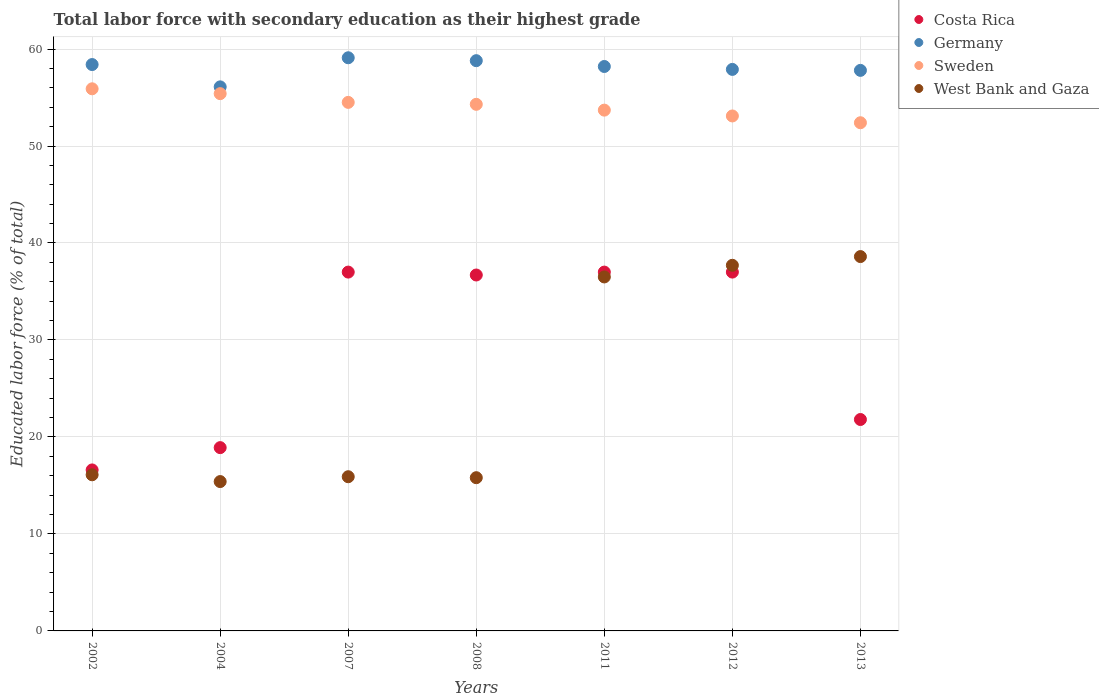How many different coloured dotlines are there?
Your answer should be compact. 4. Is the number of dotlines equal to the number of legend labels?
Keep it short and to the point. Yes. What is the percentage of total labor force with primary education in West Bank and Gaza in 2002?
Make the answer very short. 16.1. Across all years, what is the maximum percentage of total labor force with primary education in Costa Rica?
Give a very brief answer. 37. Across all years, what is the minimum percentage of total labor force with primary education in Sweden?
Give a very brief answer. 52.4. What is the total percentage of total labor force with primary education in Sweden in the graph?
Offer a terse response. 379.3. What is the difference between the percentage of total labor force with primary education in Costa Rica in 2004 and that in 2011?
Provide a succinct answer. -18.1. What is the difference between the percentage of total labor force with primary education in Sweden in 2002 and the percentage of total labor force with primary education in West Bank and Gaza in 2013?
Offer a very short reply. 17.3. What is the average percentage of total labor force with primary education in Costa Rica per year?
Your answer should be compact. 29.29. In the year 2007, what is the difference between the percentage of total labor force with primary education in Germany and percentage of total labor force with primary education in West Bank and Gaza?
Your response must be concise. 43.2. What is the ratio of the percentage of total labor force with primary education in Costa Rica in 2012 to that in 2013?
Provide a succinct answer. 1.7. Is the percentage of total labor force with primary education in Sweden in 2007 less than that in 2008?
Your answer should be very brief. No. What is the difference between the highest and the second highest percentage of total labor force with primary education in Sweden?
Offer a terse response. 0.5. Is the sum of the percentage of total labor force with primary education in Costa Rica in 2011 and 2012 greater than the maximum percentage of total labor force with primary education in West Bank and Gaza across all years?
Ensure brevity in your answer.  Yes. Is it the case that in every year, the sum of the percentage of total labor force with primary education in Germany and percentage of total labor force with primary education in West Bank and Gaza  is greater than the sum of percentage of total labor force with primary education in Sweden and percentage of total labor force with primary education in Costa Rica?
Keep it short and to the point. Yes. Does the percentage of total labor force with primary education in Germany monotonically increase over the years?
Offer a very short reply. No. Is the percentage of total labor force with primary education in West Bank and Gaza strictly greater than the percentage of total labor force with primary education in Sweden over the years?
Give a very brief answer. No. Is the percentage of total labor force with primary education in Costa Rica strictly less than the percentage of total labor force with primary education in West Bank and Gaza over the years?
Your response must be concise. No. How many dotlines are there?
Keep it short and to the point. 4. Are the values on the major ticks of Y-axis written in scientific E-notation?
Make the answer very short. No. Does the graph contain any zero values?
Your answer should be compact. No. Does the graph contain grids?
Provide a short and direct response. Yes. How are the legend labels stacked?
Offer a terse response. Vertical. What is the title of the graph?
Offer a terse response. Total labor force with secondary education as their highest grade. Does "Libya" appear as one of the legend labels in the graph?
Your answer should be compact. No. What is the label or title of the X-axis?
Provide a succinct answer. Years. What is the label or title of the Y-axis?
Your answer should be compact. Educated labor force (% of total). What is the Educated labor force (% of total) in Costa Rica in 2002?
Provide a short and direct response. 16.6. What is the Educated labor force (% of total) in Germany in 2002?
Give a very brief answer. 58.4. What is the Educated labor force (% of total) of Sweden in 2002?
Ensure brevity in your answer.  55.9. What is the Educated labor force (% of total) of West Bank and Gaza in 2002?
Provide a succinct answer. 16.1. What is the Educated labor force (% of total) in Costa Rica in 2004?
Ensure brevity in your answer.  18.9. What is the Educated labor force (% of total) of Germany in 2004?
Your answer should be very brief. 56.1. What is the Educated labor force (% of total) of Sweden in 2004?
Offer a terse response. 55.4. What is the Educated labor force (% of total) of West Bank and Gaza in 2004?
Offer a terse response. 15.4. What is the Educated labor force (% of total) in Costa Rica in 2007?
Your response must be concise. 37. What is the Educated labor force (% of total) in Germany in 2007?
Your answer should be very brief. 59.1. What is the Educated labor force (% of total) of Sweden in 2007?
Offer a very short reply. 54.5. What is the Educated labor force (% of total) in West Bank and Gaza in 2007?
Your response must be concise. 15.9. What is the Educated labor force (% of total) of Costa Rica in 2008?
Offer a very short reply. 36.7. What is the Educated labor force (% of total) in Germany in 2008?
Your answer should be very brief. 58.8. What is the Educated labor force (% of total) in Sweden in 2008?
Keep it short and to the point. 54.3. What is the Educated labor force (% of total) of West Bank and Gaza in 2008?
Ensure brevity in your answer.  15.8. What is the Educated labor force (% of total) of Germany in 2011?
Your response must be concise. 58.2. What is the Educated labor force (% of total) in Sweden in 2011?
Provide a succinct answer. 53.7. What is the Educated labor force (% of total) of West Bank and Gaza in 2011?
Provide a short and direct response. 36.5. What is the Educated labor force (% of total) of Costa Rica in 2012?
Provide a short and direct response. 37. What is the Educated labor force (% of total) of Germany in 2012?
Provide a succinct answer. 57.9. What is the Educated labor force (% of total) of Sweden in 2012?
Keep it short and to the point. 53.1. What is the Educated labor force (% of total) in West Bank and Gaza in 2012?
Offer a very short reply. 37.7. What is the Educated labor force (% of total) in Costa Rica in 2013?
Make the answer very short. 21.8. What is the Educated labor force (% of total) in Germany in 2013?
Keep it short and to the point. 57.8. What is the Educated labor force (% of total) in Sweden in 2013?
Provide a short and direct response. 52.4. What is the Educated labor force (% of total) in West Bank and Gaza in 2013?
Provide a succinct answer. 38.6. Across all years, what is the maximum Educated labor force (% of total) of Costa Rica?
Your response must be concise. 37. Across all years, what is the maximum Educated labor force (% of total) in Germany?
Make the answer very short. 59.1. Across all years, what is the maximum Educated labor force (% of total) in Sweden?
Your response must be concise. 55.9. Across all years, what is the maximum Educated labor force (% of total) in West Bank and Gaza?
Ensure brevity in your answer.  38.6. Across all years, what is the minimum Educated labor force (% of total) of Costa Rica?
Your response must be concise. 16.6. Across all years, what is the minimum Educated labor force (% of total) in Germany?
Your answer should be compact. 56.1. Across all years, what is the minimum Educated labor force (% of total) in Sweden?
Your response must be concise. 52.4. Across all years, what is the minimum Educated labor force (% of total) of West Bank and Gaza?
Your answer should be very brief. 15.4. What is the total Educated labor force (% of total) in Costa Rica in the graph?
Keep it short and to the point. 205. What is the total Educated labor force (% of total) in Germany in the graph?
Provide a succinct answer. 406.3. What is the total Educated labor force (% of total) of Sweden in the graph?
Your response must be concise. 379.3. What is the total Educated labor force (% of total) in West Bank and Gaza in the graph?
Make the answer very short. 176. What is the difference between the Educated labor force (% of total) in Costa Rica in 2002 and that in 2004?
Provide a succinct answer. -2.3. What is the difference between the Educated labor force (% of total) of West Bank and Gaza in 2002 and that in 2004?
Your answer should be very brief. 0.7. What is the difference between the Educated labor force (% of total) of Costa Rica in 2002 and that in 2007?
Offer a terse response. -20.4. What is the difference between the Educated labor force (% of total) of Germany in 2002 and that in 2007?
Offer a very short reply. -0.7. What is the difference between the Educated labor force (% of total) of Costa Rica in 2002 and that in 2008?
Ensure brevity in your answer.  -20.1. What is the difference between the Educated labor force (% of total) in West Bank and Gaza in 2002 and that in 2008?
Ensure brevity in your answer.  0.3. What is the difference between the Educated labor force (% of total) in Costa Rica in 2002 and that in 2011?
Ensure brevity in your answer.  -20.4. What is the difference between the Educated labor force (% of total) of West Bank and Gaza in 2002 and that in 2011?
Keep it short and to the point. -20.4. What is the difference between the Educated labor force (% of total) of Costa Rica in 2002 and that in 2012?
Your answer should be compact. -20.4. What is the difference between the Educated labor force (% of total) of Germany in 2002 and that in 2012?
Offer a terse response. 0.5. What is the difference between the Educated labor force (% of total) in West Bank and Gaza in 2002 and that in 2012?
Your answer should be very brief. -21.6. What is the difference between the Educated labor force (% of total) of Germany in 2002 and that in 2013?
Provide a succinct answer. 0.6. What is the difference between the Educated labor force (% of total) in West Bank and Gaza in 2002 and that in 2013?
Your answer should be very brief. -22.5. What is the difference between the Educated labor force (% of total) of Costa Rica in 2004 and that in 2007?
Your response must be concise. -18.1. What is the difference between the Educated labor force (% of total) of Costa Rica in 2004 and that in 2008?
Make the answer very short. -17.8. What is the difference between the Educated labor force (% of total) in Germany in 2004 and that in 2008?
Your response must be concise. -2.7. What is the difference between the Educated labor force (% of total) of Sweden in 2004 and that in 2008?
Provide a succinct answer. 1.1. What is the difference between the Educated labor force (% of total) of Costa Rica in 2004 and that in 2011?
Your response must be concise. -18.1. What is the difference between the Educated labor force (% of total) of West Bank and Gaza in 2004 and that in 2011?
Provide a succinct answer. -21.1. What is the difference between the Educated labor force (% of total) of Costa Rica in 2004 and that in 2012?
Provide a succinct answer. -18.1. What is the difference between the Educated labor force (% of total) of West Bank and Gaza in 2004 and that in 2012?
Offer a terse response. -22.3. What is the difference between the Educated labor force (% of total) in Germany in 2004 and that in 2013?
Ensure brevity in your answer.  -1.7. What is the difference between the Educated labor force (% of total) of Sweden in 2004 and that in 2013?
Your answer should be very brief. 3. What is the difference between the Educated labor force (% of total) of West Bank and Gaza in 2004 and that in 2013?
Give a very brief answer. -23.2. What is the difference between the Educated labor force (% of total) of Costa Rica in 2007 and that in 2008?
Ensure brevity in your answer.  0.3. What is the difference between the Educated labor force (% of total) of Germany in 2007 and that in 2008?
Offer a very short reply. 0.3. What is the difference between the Educated labor force (% of total) of Sweden in 2007 and that in 2008?
Offer a terse response. 0.2. What is the difference between the Educated labor force (% of total) of Germany in 2007 and that in 2011?
Provide a short and direct response. 0.9. What is the difference between the Educated labor force (% of total) of West Bank and Gaza in 2007 and that in 2011?
Ensure brevity in your answer.  -20.6. What is the difference between the Educated labor force (% of total) in Costa Rica in 2007 and that in 2012?
Your answer should be very brief. 0. What is the difference between the Educated labor force (% of total) in Germany in 2007 and that in 2012?
Ensure brevity in your answer.  1.2. What is the difference between the Educated labor force (% of total) of Sweden in 2007 and that in 2012?
Provide a short and direct response. 1.4. What is the difference between the Educated labor force (% of total) in West Bank and Gaza in 2007 and that in 2012?
Your answer should be compact. -21.8. What is the difference between the Educated labor force (% of total) of Costa Rica in 2007 and that in 2013?
Provide a short and direct response. 15.2. What is the difference between the Educated labor force (% of total) of Sweden in 2007 and that in 2013?
Keep it short and to the point. 2.1. What is the difference between the Educated labor force (% of total) in West Bank and Gaza in 2007 and that in 2013?
Your answer should be very brief. -22.7. What is the difference between the Educated labor force (% of total) of Costa Rica in 2008 and that in 2011?
Provide a short and direct response. -0.3. What is the difference between the Educated labor force (% of total) in Sweden in 2008 and that in 2011?
Make the answer very short. 0.6. What is the difference between the Educated labor force (% of total) in West Bank and Gaza in 2008 and that in 2011?
Offer a very short reply. -20.7. What is the difference between the Educated labor force (% of total) of Germany in 2008 and that in 2012?
Offer a terse response. 0.9. What is the difference between the Educated labor force (% of total) in Sweden in 2008 and that in 2012?
Offer a very short reply. 1.2. What is the difference between the Educated labor force (% of total) in West Bank and Gaza in 2008 and that in 2012?
Offer a terse response. -21.9. What is the difference between the Educated labor force (% of total) of Germany in 2008 and that in 2013?
Your response must be concise. 1. What is the difference between the Educated labor force (% of total) in West Bank and Gaza in 2008 and that in 2013?
Make the answer very short. -22.8. What is the difference between the Educated labor force (% of total) of Costa Rica in 2011 and that in 2012?
Your response must be concise. 0. What is the difference between the Educated labor force (% of total) of Germany in 2011 and that in 2012?
Provide a short and direct response. 0.3. What is the difference between the Educated labor force (% of total) in Sweden in 2011 and that in 2013?
Your answer should be compact. 1.3. What is the difference between the Educated labor force (% of total) in Germany in 2012 and that in 2013?
Provide a succinct answer. 0.1. What is the difference between the Educated labor force (% of total) in West Bank and Gaza in 2012 and that in 2013?
Your answer should be compact. -0.9. What is the difference between the Educated labor force (% of total) of Costa Rica in 2002 and the Educated labor force (% of total) of Germany in 2004?
Your answer should be very brief. -39.5. What is the difference between the Educated labor force (% of total) of Costa Rica in 2002 and the Educated labor force (% of total) of Sweden in 2004?
Provide a succinct answer. -38.8. What is the difference between the Educated labor force (% of total) in Costa Rica in 2002 and the Educated labor force (% of total) in West Bank and Gaza in 2004?
Provide a short and direct response. 1.2. What is the difference between the Educated labor force (% of total) in Germany in 2002 and the Educated labor force (% of total) in West Bank and Gaza in 2004?
Give a very brief answer. 43. What is the difference between the Educated labor force (% of total) in Sweden in 2002 and the Educated labor force (% of total) in West Bank and Gaza in 2004?
Ensure brevity in your answer.  40.5. What is the difference between the Educated labor force (% of total) of Costa Rica in 2002 and the Educated labor force (% of total) of Germany in 2007?
Give a very brief answer. -42.5. What is the difference between the Educated labor force (% of total) in Costa Rica in 2002 and the Educated labor force (% of total) in Sweden in 2007?
Offer a very short reply. -37.9. What is the difference between the Educated labor force (% of total) in Germany in 2002 and the Educated labor force (% of total) in Sweden in 2007?
Your answer should be very brief. 3.9. What is the difference between the Educated labor force (% of total) of Germany in 2002 and the Educated labor force (% of total) of West Bank and Gaza in 2007?
Offer a terse response. 42.5. What is the difference between the Educated labor force (% of total) of Sweden in 2002 and the Educated labor force (% of total) of West Bank and Gaza in 2007?
Make the answer very short. 40. What is the difference between the Educated labor force (% of total) of Costa Rica in 2002 and the Educated labor force (% of total) of Germany in 2008?
Your answer should be very brief. -42.2. What is the difference between the Educated labor force (% of total) in Costa Rica in 2002 and the Educated labor force (% of total) in Sweden in 2008?
Offer a terse response. -37.7. What is the difference between the Educated labor force (% of total) of Germany in 2002 and the Educated labor force (% of total) of Sweden in 2008?
Make the answer very short. 4.1. What is the difference between the Educated labor force (% of total) of Germany in 2002 and the Educated labor force (% of total) of West Bank and Gaza in 2008?
Your answer should be compact. 42.6. What is the difference between the Educated labor force (% of total) in Sweden in 2002 and the Educated labor force (% of total) in West Bank and Gaza in 2008?
Provide a short and direct response. 40.1. What is the difference between the Educated labor force (% of total) of Costa Rica in 2002 and the Educated labor force (% of total) of Germany in 2011?
Provide a short and direct response. -41.6. What is the difference between the Educated labor force (% of total) in Costa Rica in 2002 and the Educated labor force (% of total) in Sweden in 2011?
Ensure brevity in your answer.  -37.1. What is the difference between the Educated labor force (% of total) of Costa Rica in 2002 and the Educated labor force (% of total) of West Bank and Gaza in 2011?
Offer a very short reply. -19.9. What is the difference between the Educated labor force (% of total) of Germany in 2002 and the Educated labor force (% of total) of West Bank and Gaza in 2011?
Ensure brevity in your answer.  21.9. What is the difference between the Educated labor force (% of total) of Costa Rica in 2002 and the Educated labor force (% of total) of Germany in 2012?
Give a very brief answer. -41.3. What is the difference between the Educated labor force (% of total) of Costa Rica in 2002 and the Educated labor force (% of total) of Sweden in 2012?
Offer a very short reply. -36.5. What is the difference between the Educated labor force (% of total) in Costa Rica in 2002 and the Educated labor force (% of total) in West Bank and Gaza in 2012?
Your answer should be compact. -21.1. What is the difference between the Educated labor force (% of total) in Germany in 2002 and the Educated labor force (% of total) in Sweden in 2012?
Your answer should be very brief. 5.3. What is the difference between the Educated labor force (% of total) in Germany in 2002 and the Educated labor force (% of total) in West Bank and Gaza in 2012?
Your answer should be very brief. 20.7. What is the difference between the Educated labor force (% of total) of Sweden in 2002 and the Educated labor force (% of total) of West Bank and Gaza in 2012?
Your response must be concise. 18.2. What is the difference between the Educated labor force (% of total) of Costa Rica in 2002 and the Educated labor force (% of total) of Germany in 2013?
Provide a succinct answer. -41.2. What is the difference between the Educated labor force (% of total) of Costa Rica in 2002 and the Educated labor force (% of total) of Sweden in 2013?
Keep it short and to the point. -35.8. What is the difference between the Educated labor force (% of total) of Germany in 2002 and the Educated labor force (% of total) of Sweden in 2013?
Offer a very short reply. 6. What is the difference between the Educated labor force (% of total) in Germany in 2002 and the Educated labor force (% of total) in West Bank and Gaza in 2013?
Ensure brevity in your answer.  19.8. What is the difference between the Educated labor force (% of total) in Costa Rica in 2004 and the Educated labor force (% of total) in Germany in 2007?
Offer a terse response. -40.2. What is the difference between the Educated labor force (% of total) of Costa Rica in 2004 and the Educated labor force (% of total) of Sweden in 2007?
Make the answer very short. -35.6. What is the difference between the Educated labor force (% of total) in Costa Rica in 2004 and the Educated labor force (% of total) in West Bank and Gaza in 2007?
Offer a very short reply. 3. What is the difference between the Educated labor force (% of total) of Germany in 2004 and the Educated labor force (% of total) of Sweden in 2007?
Your answer should be compact. 1.6. What is the difference between the Educated labor force (% of total) in Germany in 2004 and the Educated labor force (% of total) in West Bank and Gaza in 2007?
Provide a short and direct response. 40.2. What is the difference between the Educated labor force (% of total) of Sweden in 2004 and the Educated labor force (% of total) of West Bank and Gaza in 2007?
Give a very brief answer. 39.5. What is the difference between the Educated labor force (% of total) of Costa Rica in 2004 and the Educated labor force (% of total) of Germany in 2008?
Make the answer very short. -39.9. What is the difference between the Educated labor force (% of total) of Costa Rica in 2004 and the Educated labor force (% of total) of Sweden in 2008?
Your answer should be very brief. -35.4. What is the difference between the Educated labor force (% of total) in Germany in 2004 and the Educated labor force (% of total) in Sweden in 2008?
Provide a succinct answer. 1.8. What is the difference between the Educated labor force (% of total) of Germany in 2004 and the Educated labor force (% of total) of West Bank and Gaza in 2008?
Ensure brevity in your answer.  40.3. What is the difference between the Educated labor force (% of total) of Sweden in 2004 and the Educated labor force (% of total) of West Bank and Gaza in 2008?
Make the answer very short. 39.6. What is the difference between the Educated labor force (% of total) of Costa Rica in 2004 and the Educated labor force (% of total) of Germany in 2011?
Offer a terse response. -39.3. What is the difference between the Educated labor force (% of total) of Costa Rica in 2004 and the Educated labor force (% of total) of Sweden in 2011?
Keep it short and to the point. -34.8. What is the difference between the Educated labor force (% of total) in Costa Rica in 2004 and the Educated labor force (% of total) in West Bank and Gaza in 2011?
Provide a succinct answer. -17.6. What is the difference between the Educated labor force (% of total) in Germany in 2004 and the Educated labor force (% of total) in West Bank and Gaza in 2011?
Give a very brief answer. 19.6. What is the difference between the Educated labor force (% of total) of Sweden in 2004 and the Educated labor force (% of total) of West Bank and Gaza in 2011?
Offer a terse response. 18.9. What is the difference between the Educated labor force (% of total) in Costa Rica in 2004 and the Educated labor force (% of total) in Germany in 2012?
Offer a terse response. -39. What is the difference between the Educated labor force (% of total) in Costa Rica in 2004 and the Educated labor force (% of total) in Sweden in 2012?
Provide a short and direct response. -34.2. What is the difference between the Educated labor force (% of total) in Costa Rica in 2004 and the Educated labor force (% of total) in West Bank and Gaza in 2012?
Your answer should be compact. -18.8. What is the difference between the Educated labor force (% of total) of Germany in 2004 and the Educated labor force (% of total) of West Bank and Gaza in 2012?
Your response must be concise. 18.4. What is the difference between the Educated labor force (% of total) in Costa Rica in 2004 and the Educated labor force (% of total) in Germany in 2013?
Ensure brevity in your answer.  -38.9. What is the difference between the Educated labor force (% of total) of Costa Rica in 2004 and the Educated labor force (% of total) of Sweden in 2013?
Offer a very short reply. -33.5. What is the difference between the Educated labor force (% of total) in Costa Rica in 2004 and the Educated labor force (% of total) in West Bank and Gaza in 2013?
Offer a very short reply. -19.7. What is the difference between the Educated labor force (% of total) in Germany in 2004 and the Educated labor force (% of total) in West Bank and Gaza in 2013?
Offer a very short reply. 17.5. What is the difference between the Educated labor force (% of total) in Costa Rica in 2007 and the Educated labor force (% of total) in Germany in 2008?
Give a very brief answer. -21.8. What is the difference between the Educated labor force (% of total) of Costa Rica in 2007 and the Educated labor force (% of total) of Sweden in 2008?
Your answer should be compact. -17.3. What is the difference between the Educated labor force (% of total) in Costa Rica in 2007 and the Educated labor force (% of total) in West Bank and Gaza in 2008?
Your answer should be compact. 21.2. What is the difference between the Educated labor force (% of total) of Germany in 2007 and the Educated labor force (% of total) of West Bank and Gaza in 2008?
Make the answer very short. 43.3. What is the difference between the Educated labor force (% of total) in Sweden in 2007 and the Educated labor force (% of total) in West Bank and Gaza in 2008?
Ensure brevity in your answer.  38.7. What is the difference between the Educated labor force (% of total) of Costa Rica in 2007 and the Educated labor force (% of total) of Germany in 2011?
Make the answer very short. -21.2. What is the difference between the Educated labor force (% of total) in Costa Rica in 2007 and the Educated labor force (% of total) in Sweden in 2011?
Make the answer very short. -16.7. What is the difference between the Educated labor force (% of total) of Germany in 2007 and the Educated labor force (% of total) of Sweden in 2011?
Keep it short and to the point. 5.4. What is the difference between the Educated labor force (% of total) in Germany in 2007 and the Educated labor force (% of total) in West Bank and Gaza in 2011?
Your response must be concise. 22.6. What is the difference between the Educated labor force (% of total) of Costa Rica in 2007 and the Educated labor force (% of total) of Germany in 2012?
Provide a short and direct response. -20.9. What is the difference between the Educated labor force (% of total) of Costa Rica in 2007 and the Educated labor force (% of total) of Sweden in 2012?
Provide a succinct answer. -16.1. What is the difference between the Educated labor force (% of total) of Costa Rica in 2007 and the Educated labor force (% of total) of West Bank and Gaza in 2012?
Your answer should be compact. -0.7. What is the difference between the Educated labor force (% of total) of Germany in 2007 and the Educated labor force (% of total) of West Bank and Gaza in 2012?
Your response must be concise. 21.4. What is the difference between the Educated labor force (% of total) in Sweden in 2007 and the Educated labor force (% of total) in West Bank and Gaza in 2012?
Make the answer very short. 16.8. What is the difference between the Educated labor force (% of total) of Costa Rica in 2007 and the Educated labor force (% of total) of Germany in 2013?
Offer a very short reply. -20.8. What is the difference between the Educated labor force (% of total) of Costa Rica in 2007 and the Educated labor force (% of total) of Sweden in 2013?
Offer a very short reply. -15.4. What is the difference between the Educated labor force (% of total) in Germany in 2007 and the Educated labor force (% of total) in Sweden in 2013?
Ensure brevity in your answer.  6.7. What is the difference between the Educated labor force (% of total) in Germany in 2007 and the Educated labor force (% of total) in West Bank and Gaza in 2013?
Provide a short and direct response. 20.5. What is the difference between the Educated labor force (% of total) in Costa Rica in 2008 and the Educated labor force (% of total) in Germany in 2011?
Your answer should be very brief. -21.5. What is the difference between the Educated labor force (% of total) of Costa Rica in 2008 and the Educated labor force (% of total) of Sweden in 2011?
Offer a very short reply. -17. What is the difference between the Educated labor force (% of total) in Germany in 2008 and the Educated labor force (% of total) in West Bank and Gaza in 2011?
Your response must be concise. 22.3. What is the difference between the Educated labor force (% of total) of Sweden in 2008 and the Educated labor force (% of total) of West Bank and Gaza in 2011?
Your response must be concise. 17.8. What is the difference between the Educated labor force (% of total) of Costa Rica in 2008 and the Educated labor force (% of total) of Germany in 2012?
Offer a terse response. -21.2. What is the difference between the Educated labor force (% of total) of Costa Rica in 2008 and the Educated labor force (% of total) of Sweden in 2012?
Make the answer very short. -16.4. What is the difference between the Educated labor force (% of total) in Germany in 2008 and the Educated labor force (% of total) in Sweden in 2012?
Your answer should be compact. 5.7. What is the difference between the Educated labor force (% of total) in Germany in 2008 and the Educated labor force (% of total) in West Bank and Gaza in 2012?
Keep it short and to the point. 21.1. What is the difference between the Educated labor force (% of total) in Sweden in 2008 and the Educated labor force (% of total) in West Bank and Gaza in 2012?
Offer a terse response. 16.6. What is the difference between the Educated labor force (% of total) in Costa Rica in 2008 and the Educated labor force (% of total) in Germany in 2013?
Give a very brief answer. -21.1. What is the difference between the Educated labor force (% of total) of Costa Rica in 2008 and the Educated labor force (% of total) of Sweden in 2013?
Your answer should be compact. -15.7. What is the difference between the Educated labor force (% of total) of Costa Rica in 2008 and the Educated labor force (% of total) of West Bank and Gaza in 2013?
Ensure brevity in your answer.  -1.9. What is the difference between the Educated labor force (% of total) in Germany in 2008 and the Educated labor force (% of total) in West Bank and Gaza in 2013?
Keep it short and to the point. 20.2. What is the difference between the Educated labor force (% of total) in Sweden in 2008 and the Educated labor force (% of total) in West Bank and Gaza in 2013?
Offer a terse response. 15.7. What is the difference between the Educated labor force (% of total) of Costa Rica in 2011 and the Educated labor force (% of total) of Germany in 2012?
Provide a short and direct response. -20.9. What is the difference between the Educated labor force (% of total) in Costa Rica in 2011 and the Educated labor force (% of total) in Sweden in 2012?
Offer a terse response. -16.1. What is the difference between the Educated labor force (% of total) of Costa Rica in 2011 and the Educated labor force (% of total) of West Bank and Gaza in 2012?
Ensure brevity in your answer.  -0.7. What is the difference between the Educated labor force (% of total) of Sweden in 2011 and the Educated labor force (% of total) of West Bank and Gaza in 2012?
Offer a very short reply. 16. What is the difference between the Educated labor force (% of total) in Costa Rica in 2011 and the Educated labor force (% of total) in Germany in 2013?
Offer a very short reply. -20.8. What is the difference between the Educated labor force (% of total) of Costa Rica in 2011 and the Educated labor force (% of total) of Sweden in 2013?
Ensure brevity in your answer.  -15.4. What is the difference between the Educated labor force (% of total) of Germany in 2011 and the Educated labor force (% of total) of West Bank and Gaza in 2013?
Your response must be concise. 19.6. What is the difference between the Educated labor force (% of total) of Sweden in 2011 and the Educated labor force (% of total) of West Bank and Gaza in 2013?
Provide a short and direct response. 15.1. What is the difference between the Educated labor force (% of total) in Costa Rica in 2012 and the Educated labor force (% of total) in Germany in 2013?
Offer a terse response. -20.8. What is the difference between the Educated labor force (% of total) of Costa Rica in 2012 and the Educated labor force (% of total) of Sweden in 2013?
Your response must be concise. -15.4. What is the difference between the Educated labor force (% of total) in Germany in 2012 and the Educated labor force (% of total) in West Bank and Gaza in 2013?
Give a very brief answer. 19.3. What is the average Educated labor force (% of total) of Costa Rica per year?
Ensure brevity in your answer.  29.29. What is the average Educated labor force (% of total) in Germany per year?
Ensure brevity in your answer.  58.04. What is the average Educated labor force (% of total) in Sweden per year?
Your answer should be compact. 54.19. What is the average Educated labor force (% of total) in West Bank and Gaza per year?
Keep it short and to the point. 25.14. In the year 2002, what is the difference between the Educated labor force (% of total) in Costa Rica and Educated labor force (% of total) in Germany?
Give a very brief answer. -41.8. In the year 2002, what is the difference between the Educated labor force (% of total) of Costa Rica and Educated labor force (% of total) of Sweden?
Make the answer very short. -39.3. In the year 2002, what is the difference between the Educated labor force (% of total) in Germany and Educated labor force (% of total) in West Bank and Gaza?
Offer a very short reply. 42.3. In the year 2002, what is the difference between the Educated labor force (% of total) in Sweden and Educated labor force (% of total) in West Bank and Gaza?
Your answer should be compact. 39.8. In the year 2004, what is the difference between the Educated labor force (% of total) of Costa Rica and Educated labor force (% of total) of Germany?
Your response must be concise. -37.2. In the year 2004, what is the difference between the Educated labor force (% of total) of Costa Rica and Educated labor force (% of total) of Sweden?
Keep it short and to the point. -36.5. In the year 2004, what is the difference between the Educated labor force (% of total) in Germany and Educated labor force (% of total) in West Bank and Gaza?
Give a very brief answer. 40.7. In the year 2004, what is the difference between the Educated labor force (% of total) in Sweden and Educated labor force (% of total) in West Bank and Gaza?
Give a very brief answer. 40. In the year 2007, what is the difference between the Educated labor force (% of total) in Costa Rica and Educated labor force (% of total) in Germany?
Provide a succinct answer. -22.1. In the year 2007, what is the difference between the Educated labor force (% of total) in Costa Rica and Educated labor force (% of total) in Sweden?
Give a very brief answer. -17.5. In the year 2007, what is the difference between the Educated labor force (% of total) of Costa Rica and Educated labor force (% of total) of West Bank and Gaza?
Your response must be concise. 21.1. In the year 2007, what is the difference between the Educated labor force (% of total) in Germany and Educated labor force (% of total) in Sweden?
Provide a short and direct response. 4.6. In the year 2007, what is the difference between the Educated labor force (% of total) in Germany and Educated labor force (% of total) in West Bank and Gaza?
Your answer should be compact. 43.2. In the year 2007, what is the difference between the Educated labor force (% of total) in Sweden and Educated labor force (% of total) in West Bank and Gaza?
Your answer should be compact. 38.6. In the year 2008, what is the difference between the Educated labor force (% of total) in Costa Rica and Educated labor force (% of total) in Germany?
Offer a terse response. -22.1. In the year 2008, what is the difference between the Educated labor force (% of total) in Costa Rica and Educated labor force (% of total) in Sweden?
Give a very brief answer. -17.6. In the year 2008, what is the difference between the Educated labor force (% of total) in Costa Rica and Educated labor force (% of total) in West Bank and Gaza?
Make the answer very short. 20.9. In the year 2008, what is the difference between the Educated labor force (% of total) in Sweden and Educated labor force (% of total) in West Bank and Gaza?
Offer a terse response. 38.5. In the year 2011, what is the difference between the Educated labor force (% of total) in Costa Rica and Educated labor force (% of total) in Germany?
Provide a succinct answer. -21.2. In the year 2011, what is the difference between the Educated labor force (% of total) in Costa Rica and Educated labor force (% of total) in Sweden?
Give a very brief answer. -16.7. In the year 2011, what is the difference between the Educated labor force (% of total) in Germany and Educated labor force (% of total) in Sweden?
Give a very brief answer. 4.5. In the year 2011, what is the difference between the Educated labor force (% of total) of Germany and Educated labor force (% of total) of West Bank and Gaza?
Your answer should be very brief. 21.7. In the year 2011, what is the difference between the Educated labor force (% of total) of Sweden and Educated labor force (% of total) of West Bank and Gaza?
Your answer should be compact. 17.2. In the year 2012, what is the difference between the Educated labor force (% of total) of Costa Rica and Educated labor force (% of total) of Germany?
Provide a succinct answer. -20.9. In the year 2012, what is the difference between the Educated labor force (% of total) of Costa Rica and Educated labor force (% of total) of Sweden?
Keep it short and to the point. -16.1. In the year 2012, what is the difference between the Educated labor force (% of total) of Germany and Educated labor force (% of total) of Sweden?
Make the answer very short. 4.8. In the year 2012, what is the difference between the Educated labor force (% of total) in Germany and Educated labor force (% of total) in West Bank and Gaza?
Your answer should be very brief. 20.2. In the year 2013, what is the difference between the Educated labor force (% of total) in Costa Rica and Educated labor force (% of total) in Germany?
Give a very brief answer. -36. In the year 2013, what is the difference between the Educated labor force (% of total) in Costa Rica and Educated labor force (% of total) in Sweden?
Offer a very short reply. -30.6. In the year 2013, what is the difference between the Educated labor force (% of total) in Costa Rica and Educated labor force (% of total) in West Bank and Gaza?
Make the answer very short. -16.8. In the year 2013, what is the difference between the Educated labor force (% of total) of Germany and Educated labor force (% of total) of West Bank and Gaza?
Provide a succinct answer. 19.2. In the year 2013, what is the difference between the Educated labor force (% of total) in Sweden and Educated labor force (% of total) in West Bank and Gaza?
Keep it short and to the point. 13.8. What is the ratio of the Educated labor force (% of total) of Costa Rica in 2002 to that in 2004?
Your response must be concise. 0.88. What is the ratio of the Educated labor force (% of total) of Germany in 2002 to that in 2004?
Give a very brief answer. 1.04. What is the ratio of the Educated labor force (% of total) in Sweden in 2002 to that in 2004?
Your answer should be compact. 1.01. What is the ratio of the Educated labor force (% of total) in West Bank and Gaza in 2002 to that in 2004?
Provide a short and direct response. 1.05. What is the ratio of the Educated labor force (% of total) of Costa Rica in 2002 to that in 2007?
Your response must be concise. 0.45. What is the ratio of the Educated labor force (% of total) in Sweden in 2002 to that in 2007?
Ensure brevity in your answer.  1.03. What is the ratio of the Educated labor force (% of total) of West Bank and Gaza in 2002 to that in 2007?
Your answer should be compact. 1.01. What is the ratio of the Educated labor force (% of total) of Costa Rica in 2002 to that in 2008?
Make the answer very short. 0.45. What is the ratio of the Educated labor force (% of total) in Germany in 2002 to that in 2008?
Keep it short and to the point. 0.99. What is the ratio of the Educated labor force (% of total) in Sweden in 2002 to that in 2008?
Your answer should be very brief. 1.03. What is the ratio of the Educated labor force (% of total) of Costa Rica in 2002 to that in 2011?
Your response must be concise. 0.45. What is the ratio of the Educated labor force (% of total) of Germany in 2002 to that in 2011?
Offer a terse response. 1. What is the ratio of the Educated labor force (% of total) in Sweden in 2002 to that in 2011?
Provide a succinct answer. 1.04. What is the ratio of the Educated labor force (% of total) of West Bank and Gaza in 2002 to that in 2011?
Ensure brevity in your answer.  0.44. What is the ratio of the Educated labor force (% of total) of Costa Rica in 2002 to that in 2012?
Your response must be concise. 0.45. What is the ratio of the Educated labor force (% of total) in Germany in 2002 to that in 2012?
Make the answer very short. 1.01. What is the ratio of the Educated labor force (% of total) of Sweden in 2002 to that in 2012?
Provide a succinct answer. 1.05. What is the ratio of the Educated labor force (% of total) of West Bank and Gaza in 2002 to that in 2012?
Your answer should be compact. 0.43. What is the ratio of the Educated labor force (% of total) of Costa Rica in 2002 to that in 2013?
Your answer should be compact. 0.76. What is the ratio of the Educated labor force (% of total) in Germany in 2002 to that in 2013?
Your response must be concise. 1.01. What is the ratio of the Educated labor force (% of total) in Sweden in 2002 to that in 2013?
Your response must be concise. 1.07. What is the ratio of the Educated labor force (% of total) in West Bank and Gaza in 2002 to that in 2013?
Your answer should be compact. 0.42. What is the ratio of the Educated labor force (% of total) in Costa Rica in 2004 to that in 2007?
Provide a succinct answer. 0.51. What is the ratio of the Educated labor force (% of total) of Germany in 2004 to that in 2007?
Give a very brief answer. 0.95. What is the ratio of the Educated labor force (% of total) in Sweden in 2004 to that in 2007?
Your answer should be very brief. 1.02. What is the ratio of the Educated labor force (% of total) in West Bank and Gaza in 2004 to that in 2007?
Keep it short and to the point. 0.97. What is the ratio of the Educated labor force (% of total) of Costa Rica in 2004 to that in 2008?
Provide a short and direct response. 0.52. What is the ratio of the Educated labor force (% of total) in Germany in 2004 to that in 2008?
Offer a terse response. 0.95. What is the ratio of the Educated labor force (% of total) in Sweden in 2004 to that in 2008?
Ensure brevity in your answer.  1.02. What is the ratio of the Educated labor force (% of total) of West Bank and Gaza in 2004 to that in 2008?
Your answer should be very brief. 0.97. What is the ratio of the Educated labor force (% of total) in Costa Rica in 2004 to that in 2011?
Your response must be concise. 0.51. What is the ratio of the Educated labor force (% of total) of Germany in 2004 to that in 2011?
Your answer should be very brief. 0.96. What is the ratio of the Educated labor force (% of total) of Sweden in 2004 to that in 2011?
Ensure brevity in your answer.  1.03. What is the ratio of the Educated labor force (% of total) of West Bank and Gaza in 2004 to that in 2011?
Ensure brevity in your answer.  0.42. What is the ratio of the Educated labor force (% of total) in Costa Rica in 2004 to that in 2012?
Give a very brief answer. 0.51. What is the ratio of the Educated labor force (% of total) in Germany in 2004 to that in 2012?
Your answer should be very brief. 0.97. What is the ratio of the Educated labor force (% of total) of Sweden in 2004 to that in 2012?
Your answer should be very brief. 1.04. What is the ratio of the Educated labor force (% of total) of West Bank and Gaza in 2004 to that in 2012?
Provide a succinct answer. 0.41. What is the ratio of the Educated labor force (% of total) in Costa Rica in 2004 to that in 2013?
Provide a short and direct response. 0.87. What is the ratio of the Educated labor force (% of total) of Germany in 2004 to that in 2013?
Your response must be concise. 0.97. What is the ratio of the Educated labor force (% of total) of Sweden in 2004 to that in 2013?
Provide a short and direct response. 1.06. What is the ratio of the Educated labor force (% of total) of West Bank and Gaza in 2004 to that in 2013?
Give a very brief answer. 0.4. What is the ratio of the Educated labor force (% of total) in Costa Rica in 2007 to that in 2008?
Offer a terse response. 1.01. What is the ratio of the Educated labor force (% of total) in West Bank and Gaza in 2007 to that in 2008?
Your response must be concise. 1.01. What is the ratio of the Educated labor force (% of total) in Germany in 2007 to that in 2011?
Your answer should be very brief. 1.02. What is the ratio of the Educated labor force (% of total) of Sweden in 2007 to that in 2011?
Your answer should be compact. 1.01. What is the ratio of the Educated labor force (% of total) in West Bank and Gaza in 2007 to that in 2011?
Offer a very short reply. 0.44. What is the ratio of the Educated labor force (% of total) in Costa Rica in 2007 to that in 2012?
Ensure brevity in your answer.  1. What is the ratio of the Educated labor force (% of total) in Germany in 2007 to that in 2012?
Keep it short and to the point. 1.02. What is the ratio of the Educated labor force (% of total) of Sweden in 2007 to that in 2012?
Your answer should be very brief. 1.03. What is the ratio of the Educated labor force (% of total) of West Bank and Gaza in 2007 to that in 2012?
Your answer should be compact. 0.42. What is the ratio of the Educated labor force (% of total) of Costa Rica in 2007 to that in 2013?
Provide a short and direct response. 1.7. What is the ratio of the Educated labor force (% of total) of Germany in 2007 to that in 2013?
Keep it short and to the point. 1.02. What is the ratio of the Educated labor force (% of total) of Sweden in 2007 to that in 2013?
Your response must be concise. 1.04. What is the ratio of the Educated labor force (% of total) in West Bank and Gaza in 2007 to that in 2013?
Ensure brevity in your answer.  0.41. What is the ratio of the Educated labor force (% of total) of Costa Rica in 2008 to that in 2011?
Offer a very short reply. 0.99. What is the ratio of the Educated labor force (% of total) in Germany in 2008 to that in 2011?
Your answer should be compact. 1.01. What is the ratio of the Educated labor force (% of total) of Sweden in 2008 to that in 2011?
Offer a terse response. 1.01. What is the ratio of the Educated labor force (% of total) of West Bank and Gaza in 2008 to that in 2011?
Give a very brief answer. 0.43. What is the ratio of the Educated labor force (% of total) of Costa Rica in 2008 to that in 2012?
Make the answer very short. 0.99. What is the ratio of the Educated labor force (% of total) of Germany in 2008 to that in 2012?
Your answer should be very brief. 1.02. What is the ratio of the Educated labor force (% of total) of Sweden in 2008 to that in 2012?
Provide a succinct answer. 1.02. What is the ratio of the Educated labor force (% of total) in West Bank and Gaza in 2008 to that in 2012?
Your answer should be very brief. 0.42. What is the ratio of the Educated labor force (% of total) in Costa Rica in 2008 to that in 2013?
Your answer should be very brief. 1.68. What is the ratio of the Educated labor force (% of total) in Germany in 2008 to that in 2013?
Provide a short and direct response. 1.02. What is the ratio of the Educated labor force (% of total) of Sweden in 2008 to that in 2013?
Provide a short and direct response. 1.04. What is the ratio of the Educated labor force (% of total) of West Bank and Gaza in 2008 to that in 2013?
Your answer should be compact. 0.41. What is the ratio of the Educated labor force (% of total) in Costa Rica in 2011 to that in 2012?
Your answer should be compact. 1. What is the ratio of the Educated labor force (% of total) of Sweden in 2011 to that in 2012?
Offer a very short reply. 1.01. What is the ratio of the Educated labor force (% of total) of West Bank and Gaza in 2011 to that in 2012?
Your answer should be very brief. 0.97. What is the ratio of the Educated labor force (% of total) in Costa Rica in 2011 to that in 2013?
Your answer should be very brief. 1.7. What is the ratio of the Educated labor force (% of total) of Germany in 2011 to that in 2013?
Make the answer very short. 1.01. What is the ratio of the Educated labor force (% of total) in Sweden in 2011 to that in 2013?
Make the answer very short. 1.02. What is the ratio of the Educated labor force (% of total) in West Bank and Gaza in 2011 to that in 2013?
Your answer should be compact. 0.95. What is the ratio of the Educated labor force (% of total) in Costa Rica in 2012 to that in 2013?
Provide a succinct answer. 1.7. What is the ratio of the Educated labor force (% of total) of Sweden in 2012 to that in 2013?
Offer a very short reply. 1.01. What is the ratio of the Educated labor force (% of total) in West Bank and Gaza in 2012 to that in 2013?
Offer a terse response. 0.98. What is the difference between the highest and the second highest Educated labor force (% of total) in Costa Rica?
Your answer should be compact. 0. What is the difference between the highest and the second highest Educated labor force (% of total) of Germany?
Provide a short and direct response. 0.3. What is the difference between the highest and the second highest Educated labor force (% of total) of Sweden?
Make the answer very short. 0.5. What is the difference between the highest and the second highest Educated labor force (% of total) in West Bank and Gaza?
Ensure brevity in your answer.  0.9. What is the difference between the highest and the lowest Educated labor force (% of total) in Costa Rica?
Offer a terse response. 20.4. What is the difference between the highest and the lowest Educated labor force (% of total) in Germany?
Your response must be concise. 3. What is the difference between the highest and the lowest Educated labor force (% of total) in West Bank and Gaza?
Your response must be concise. 23.2. 